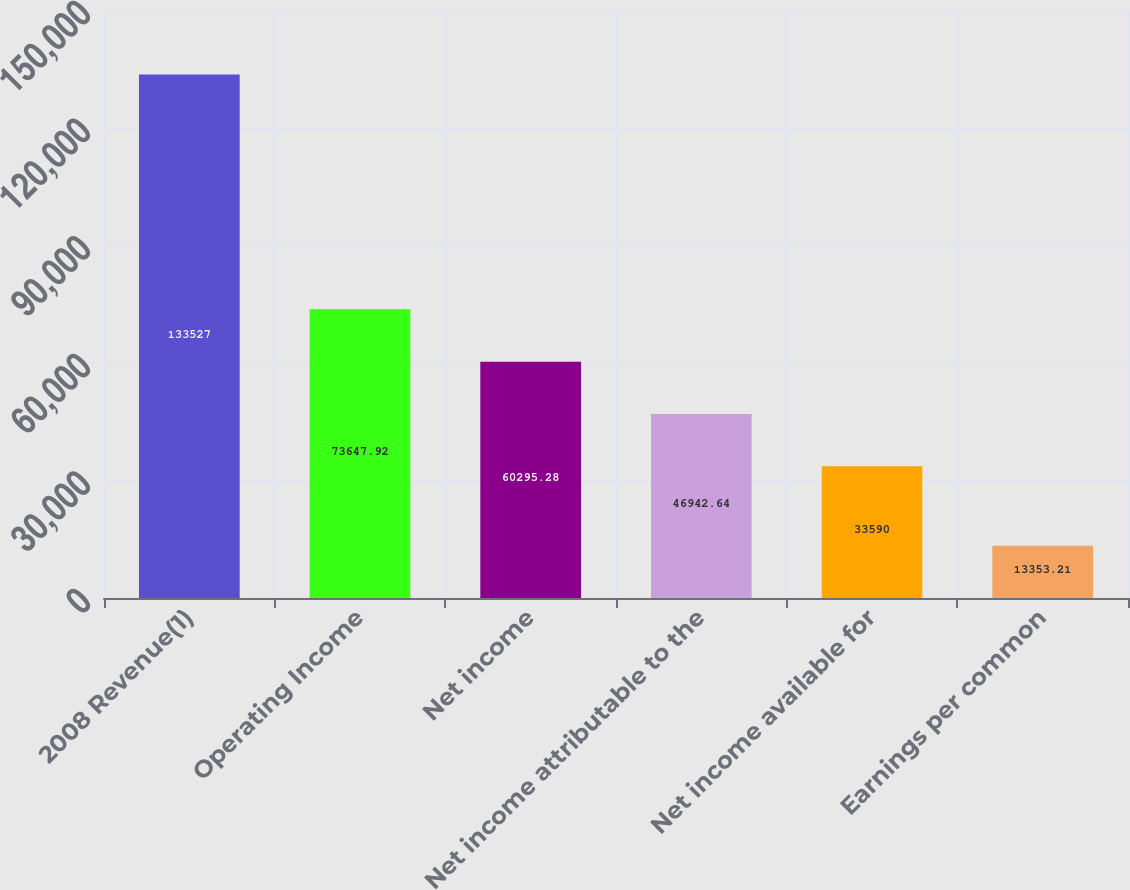Convert chart. <chart><loc_0><loc_0><loc_500><loc_500><bar_chart><fcel>2008 Revenue(1)<fcel>Operating Income<fcel>Net income<fcel>Net income attributable to the<fcel>Net income available for<fcel>Earnings per common<nl><fcel>133527<fcel>73647.9<fcel>60295.3<fcel>46942.6<fcel>33590<fcel>13353.2<nl></chart> 